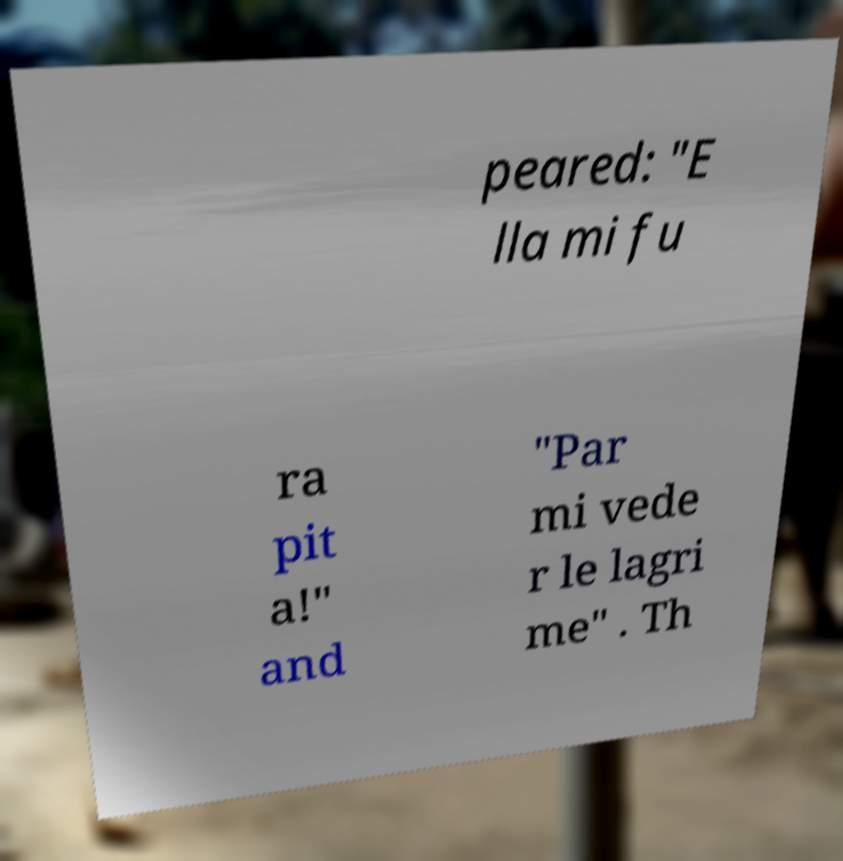Could you extract and type out the text from this image? peared: "E lla mi fu ra pit a!" and "Par mi vede r le lagri me" . Th 